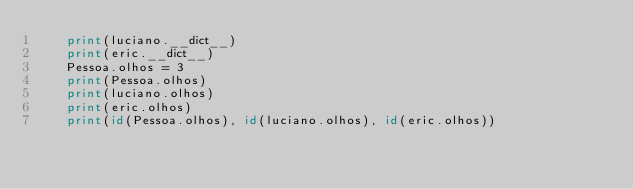<code> <loc_0><loc_0><loc_500><loc_500><_Python_>    print(luciano.__dict__)
    print(eric.__dict__)
    Pessoa.olhos = 3
    print(Pessoa.olhos)
    print(luciano.olhos)
    print(eric.olhos)
    print(id(Pessoa.olhos), id(luciano.olhos), id(eric.olhos))

</code> 